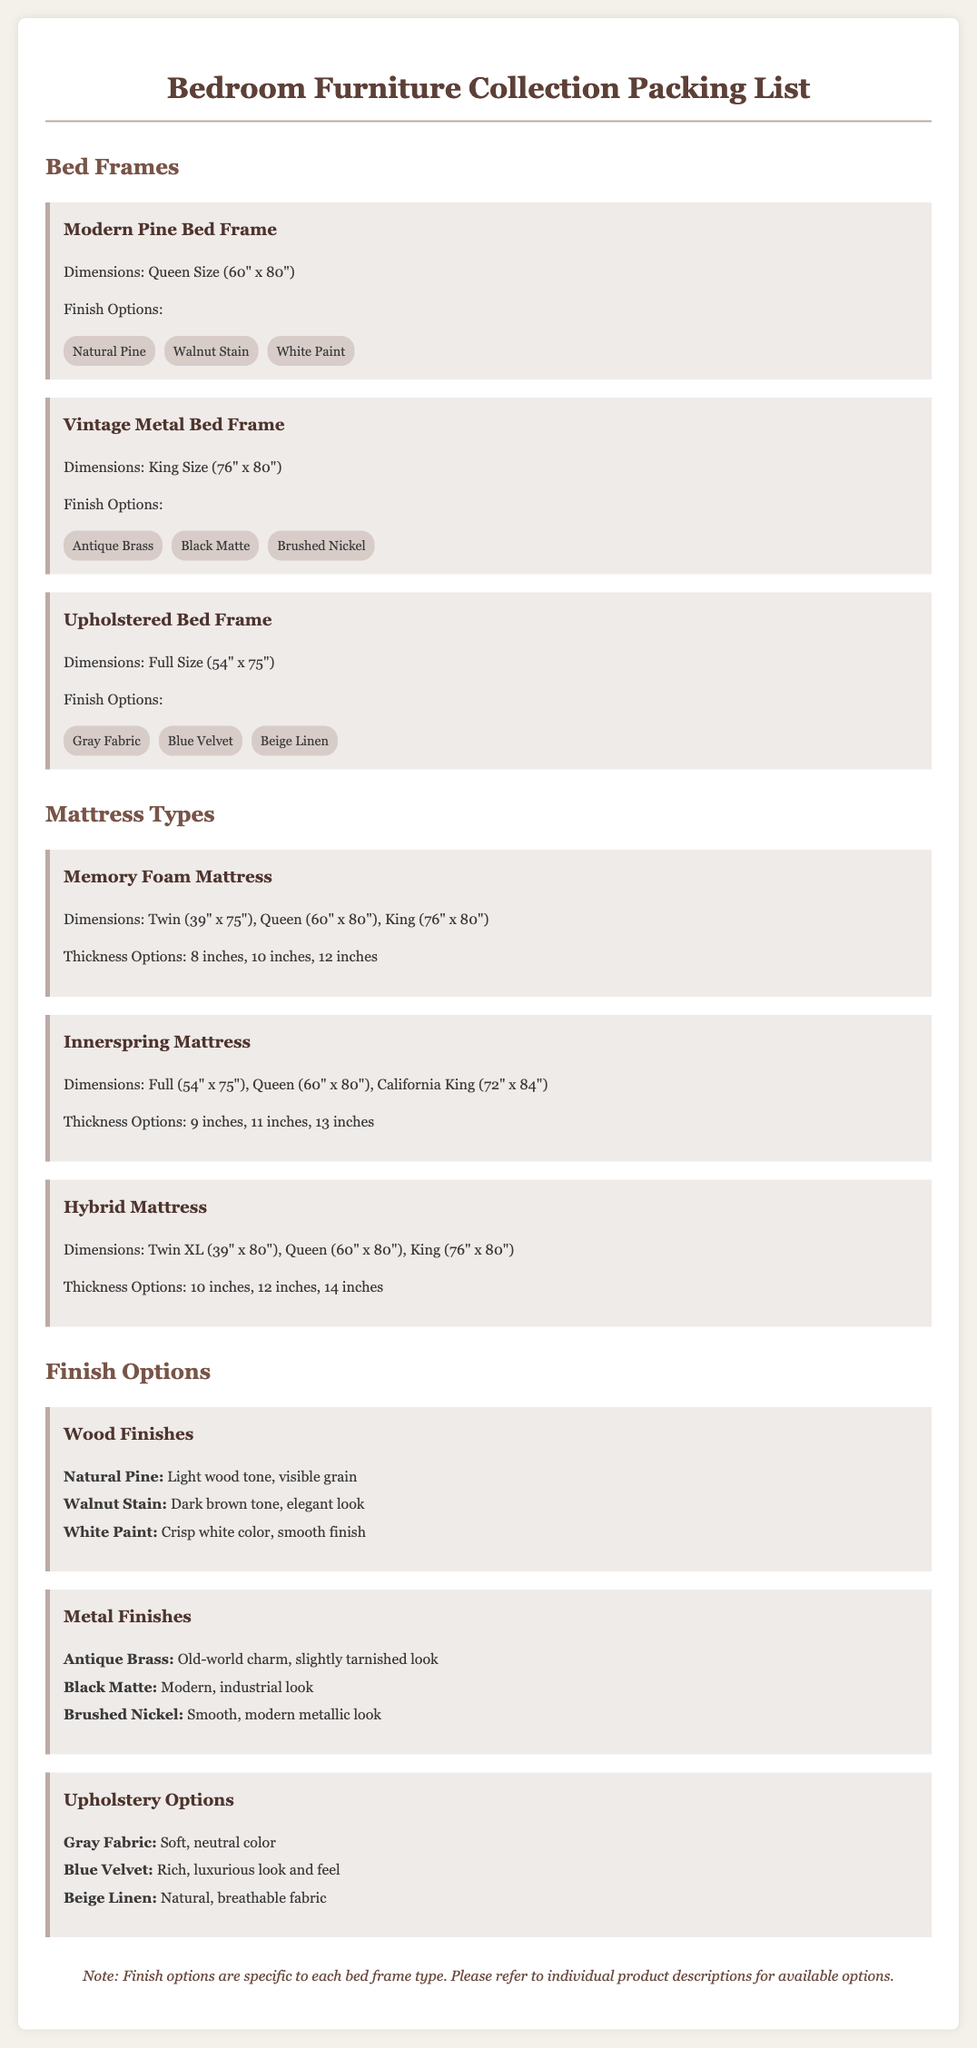What are the dimensions of the Modern Pine Bed Frame? The dimensions provided for the Modern Pine Bed Frame are Queen Size (60" x 80").
Answer: Queen Size (60" x 80") How many thickness options does the Memory Foam Mattress have? The Memory Foam Mattress has three thickness options: 8 inches, 10 inches, 12 inches.
Answer: 3 What finish options are available for the Vintage Metal Bed Frame? The available finish options for the Vintage Metal Bed Frame are Antique Brass, Black Matte, and Brushed Nickel.
Answer: Antique Brass, Black Matte, Brushed Nickel What type of upholstery option is available for the Upholstered Bed Frame? The upholstery options listed for the Upholstered Bed Frame include Gray Fabric, Blue Velvet, and Beige Linen.
Answer: Gray Fabric, Blue Velvet, Beige Linen What is one finish option for the Innerspring Mattress? The Innerspring Mattress offers dimensions but does not provide specific finish options since it is a mattress type, not a frame; thus, the question is misleading.
Answer: N/A How many bed frame types are listed in the document? The document lists three types of bed frames: Modern Pine, Vintage Metal, and Upholstered Bed Frame.
Answer: 3 What is the thickness of the Hybrid Mattress? The Hybrid Mattress provides three thickness options: 10 inches, 12 inches, and 14 inches, but does not specify a singular thickness.
Answer: N/A Which wood finish option has a dark brown tone? The Walnut Stain is the wood finish option that has a dark brown tone.
Answer: Walnut Stain What is the note at the end of the document regarding finish options? The note explains that finish options are specific to each bed frame type and suggests referring to individual product descriptions for details.
Answer: Finish options are specific to each bed frame type 